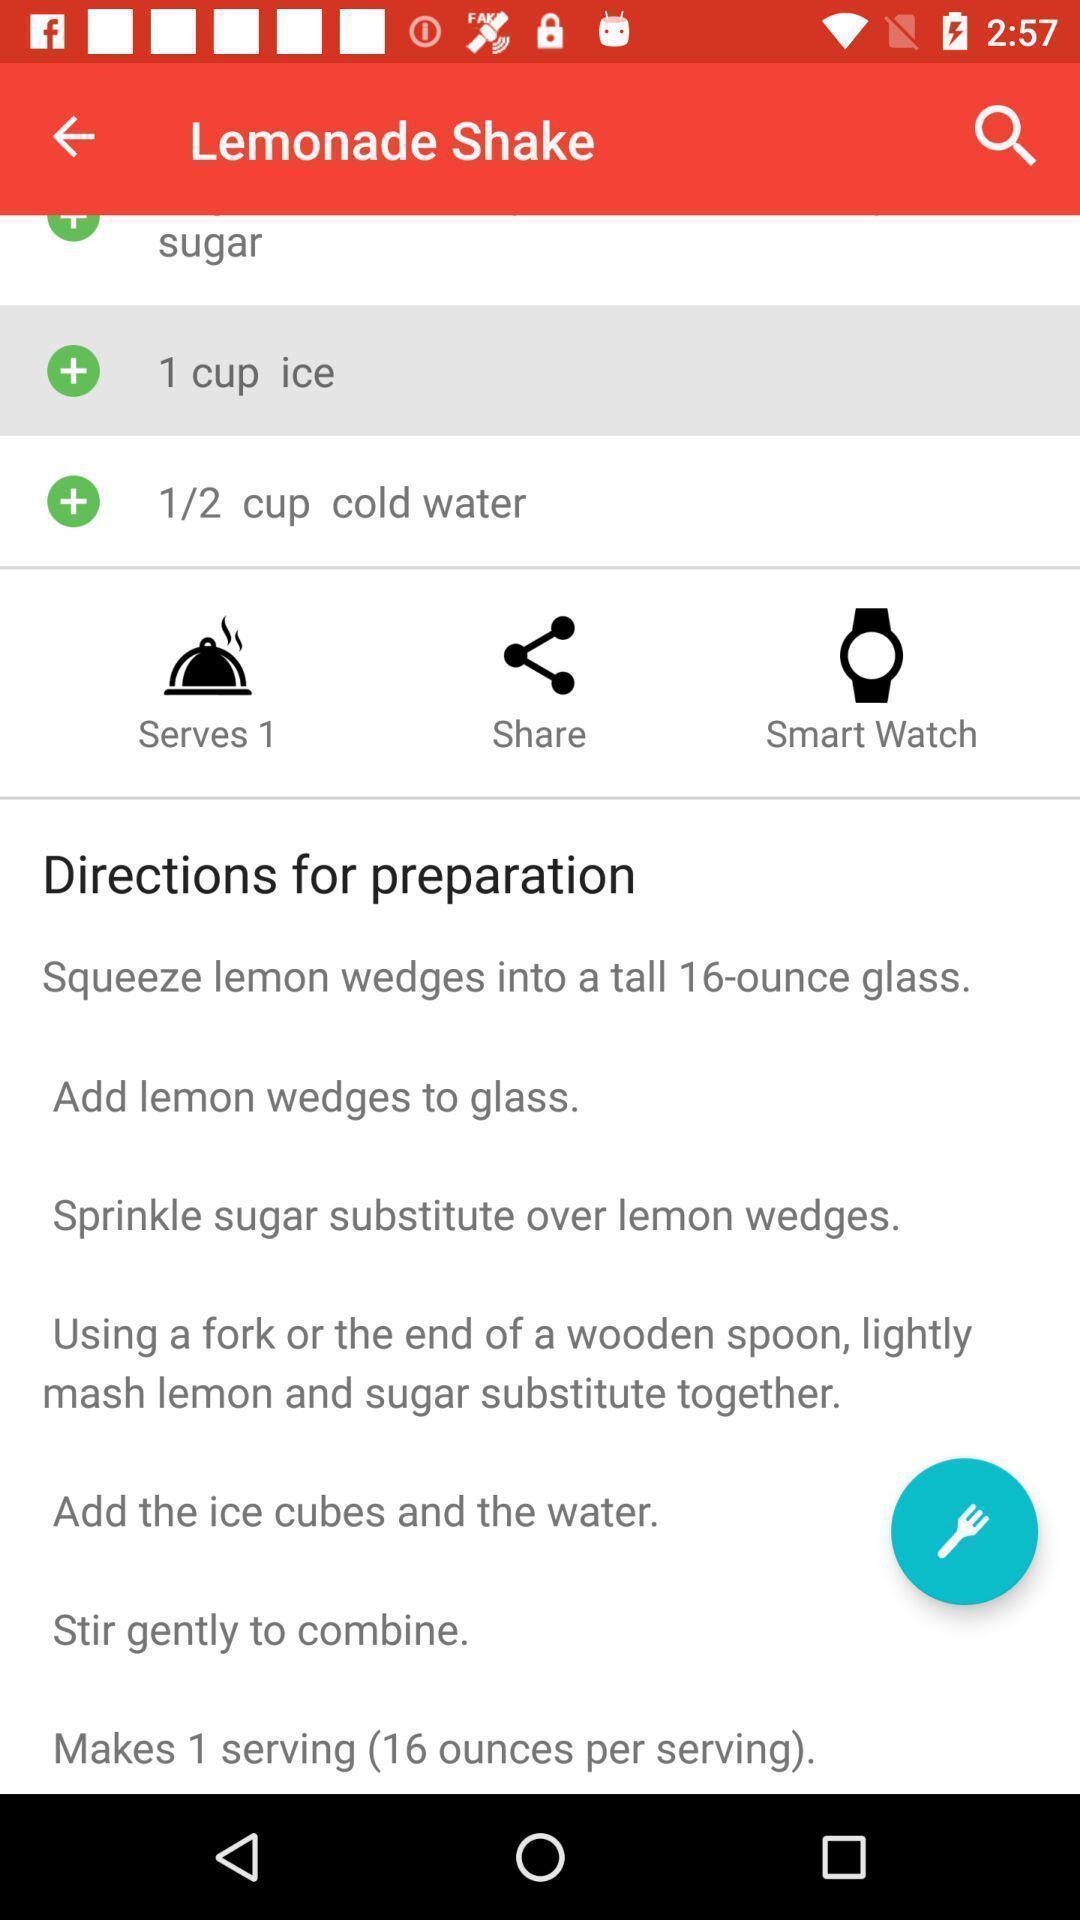Give me a narrative description of this picture. Screen showing recipe details in a cooking app. 